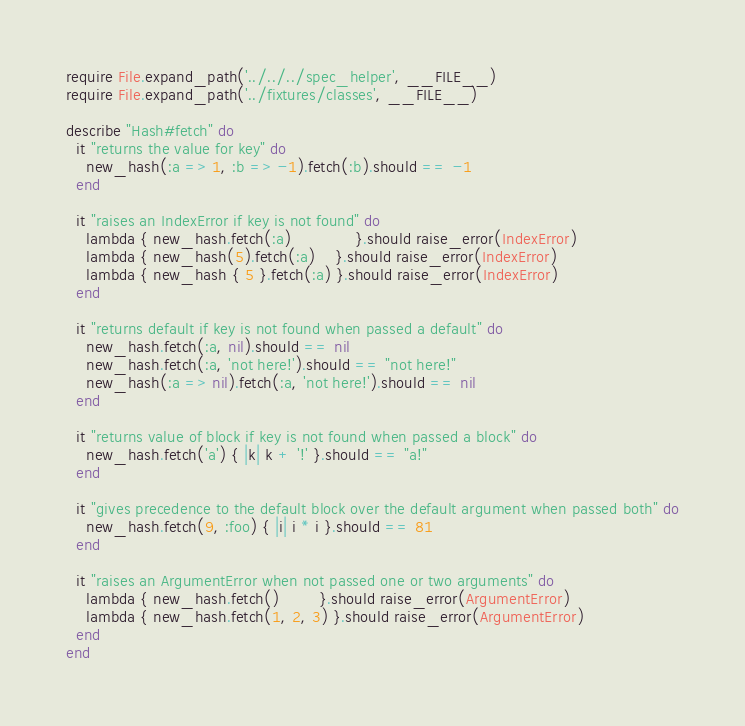<code> <loc_0><loc_0><loc_500><loc_500><_Ruby_>require File.expand_path('../../../spec_helper', __FILE__)
require File.expand_path('../fixtures/classes', __FILE__)

describe "Hash#fetch" do
  it "returns the value for key" do
    new_hash(:a => 1, :b => -1).fetch(:b).should == -1
  end

  it "raises an IndexError if key is not found" do
    lambda { new_hash.fetch(:a)             }.should raise_error(IndexError)
    lambda { new_hash(5).fetch(:a)    }.should raise_error(IndexError)
    lambda { new_hash { 5 }.fetch(:a) }.should raise_error(IndexError)
  end

  it "returns default if key is not found when passed a default" do
    new_hash.fetch(:a, nil).should == nil
    new_hash.fetch(:a, 'not here!').should == "not here!"
    new_hash(:a => nil).fetch(:a, 'not here!').should == nil
  end

  it "returns value of block if key is not found when passed a block" do
    new_hash.fetch('a') { |k| k + '!' }.should == "a!"
  end

  it "gives precedence to the default block over the default argument when passed both" do
    new_hash.fetch(9, :foo) { |i| i * i }.should == 81
  end

  it "raises an ArgumentError when not passed one or two arguments" do
    lambda { new_hash.fetch()        }.should raise_error(ArgumentError)
    lambda { new_hash.fetch(1, 2, 3) }.should raise_error(ArgumentError)
  end
end
</code> 